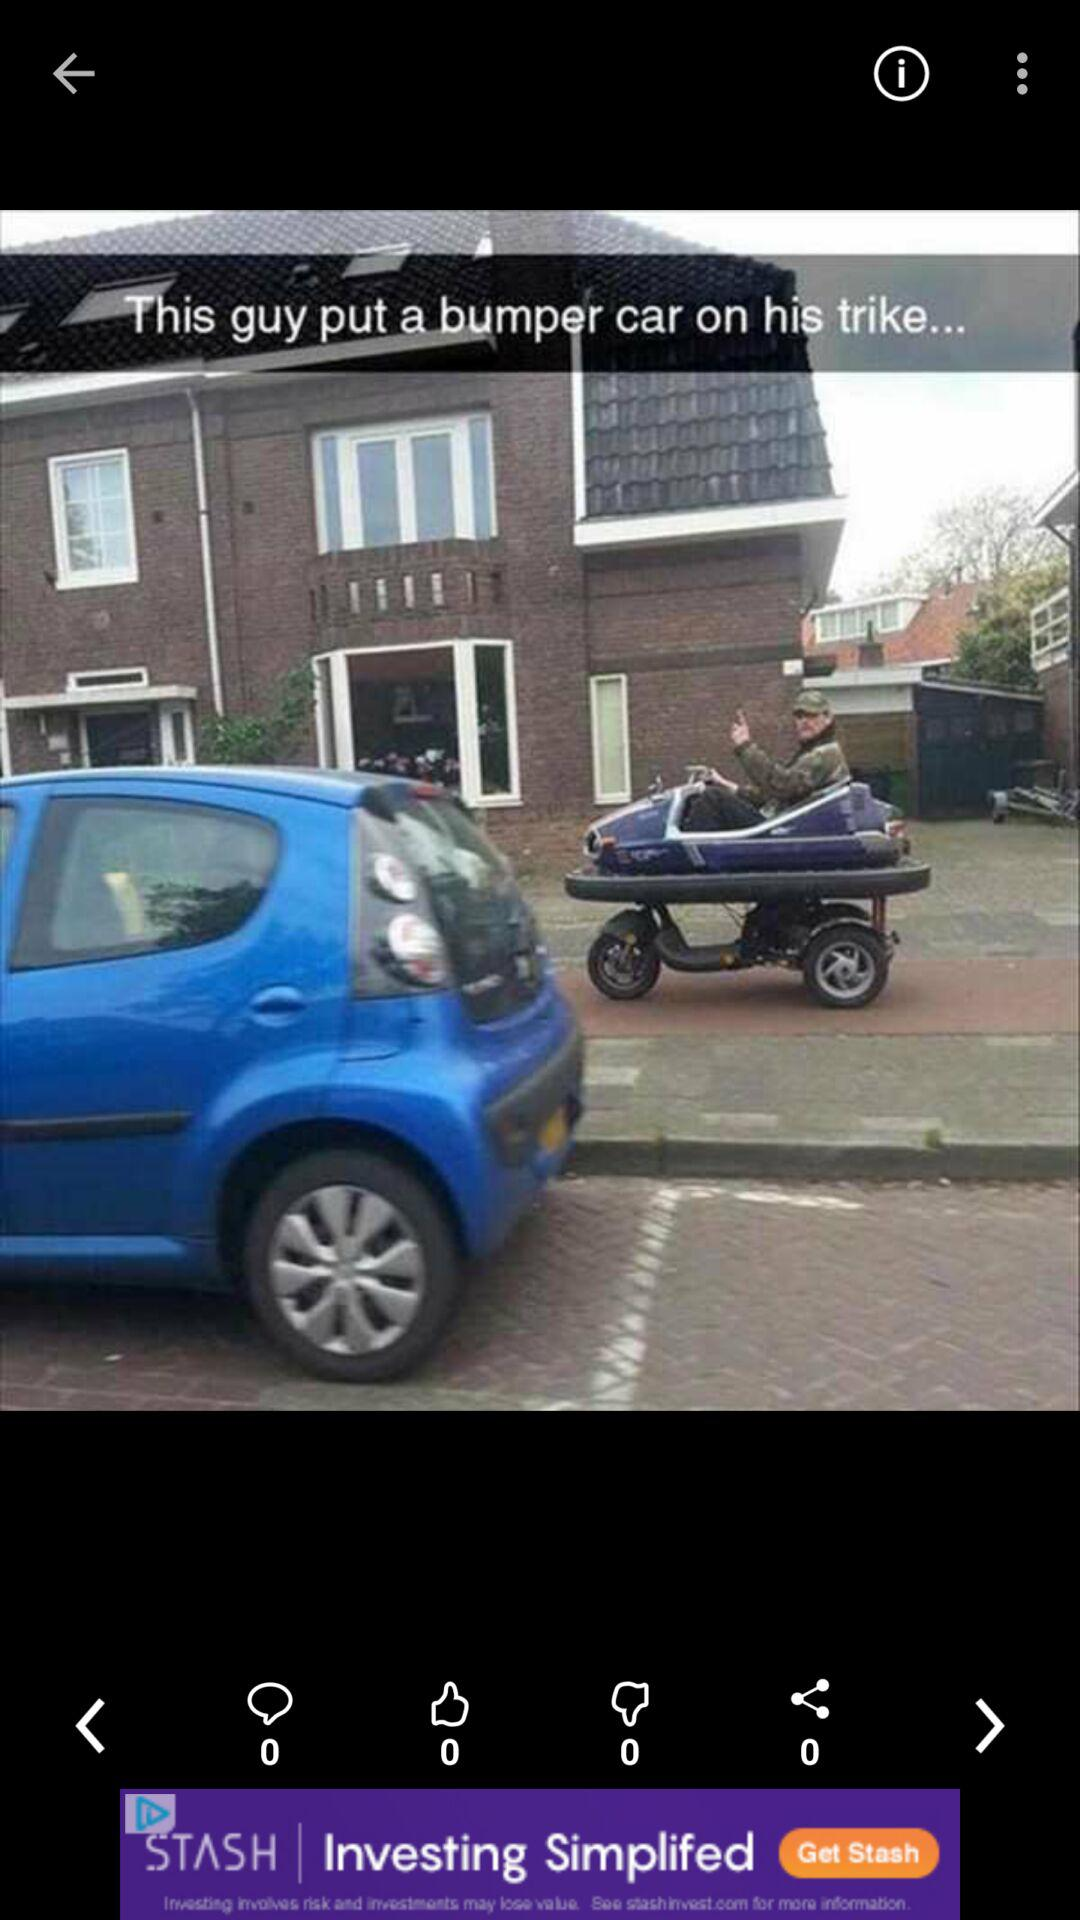How many likes are there on the post? There are 0 likes on the post. 